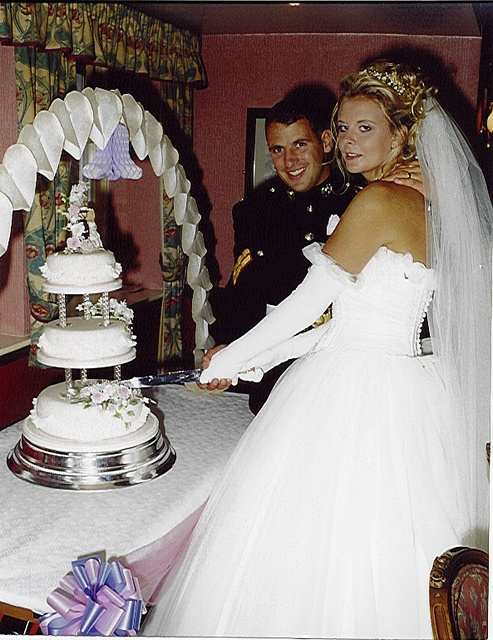Describe the objects in this image and their specific colors. I can see people in black, lightgray, darkgray, tan, and gray tones, dining table in black, lightgray, darkgray, gray, and maroon tones, cake in black, lightgray, darkgray, and gray tones, people in black, maroon, and gray tones, and chair in black, maroon, and gray tones in this image. 